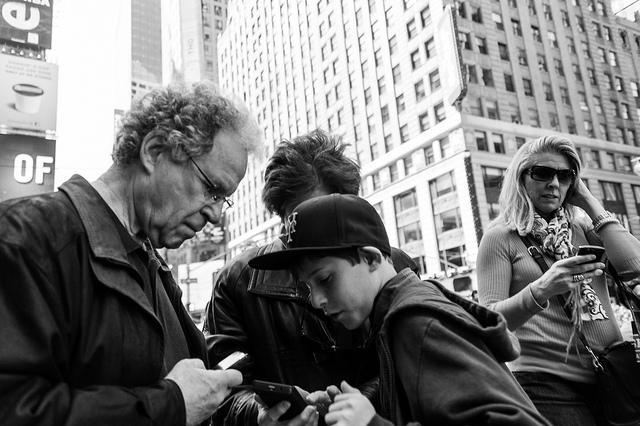What does the boy have on his head? Please explain your reasoning. baseball cap. The boy is wearing a hat. 